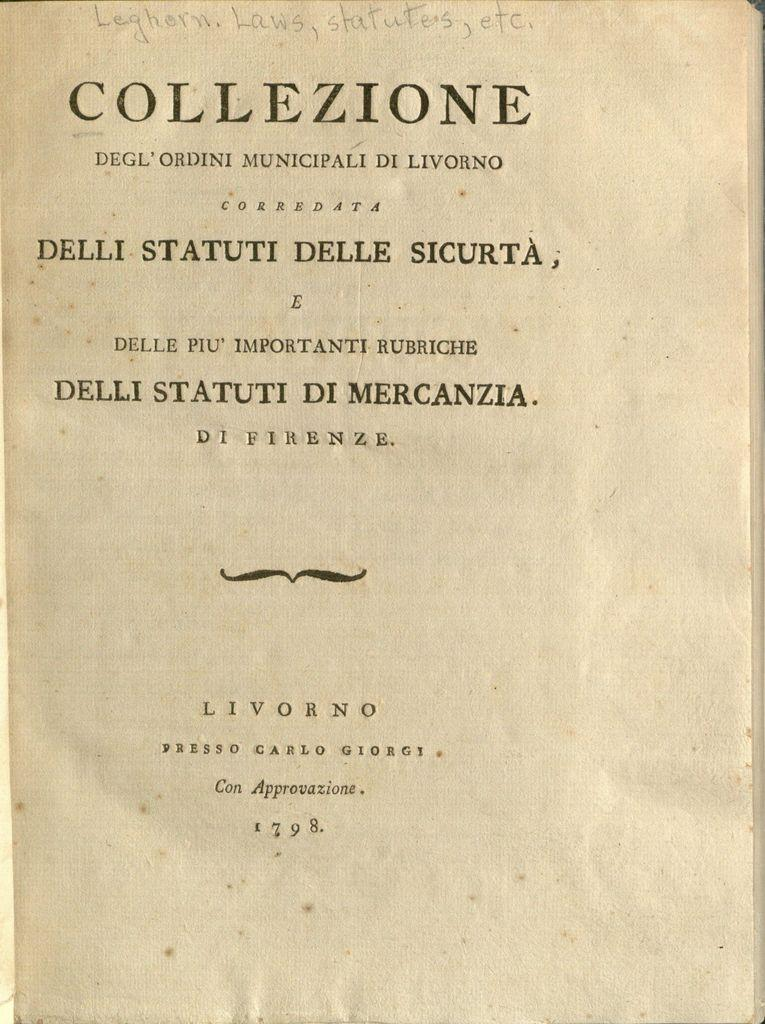Provide a one-sentence caption for the provided image. An old book from 1798 is titled Collezione. 